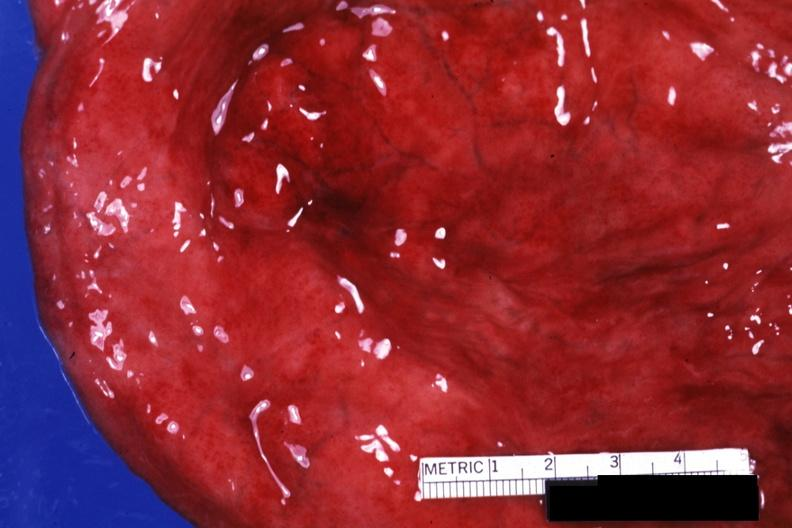s urinary present?
Answer the question using a single word or phrase. Yes 